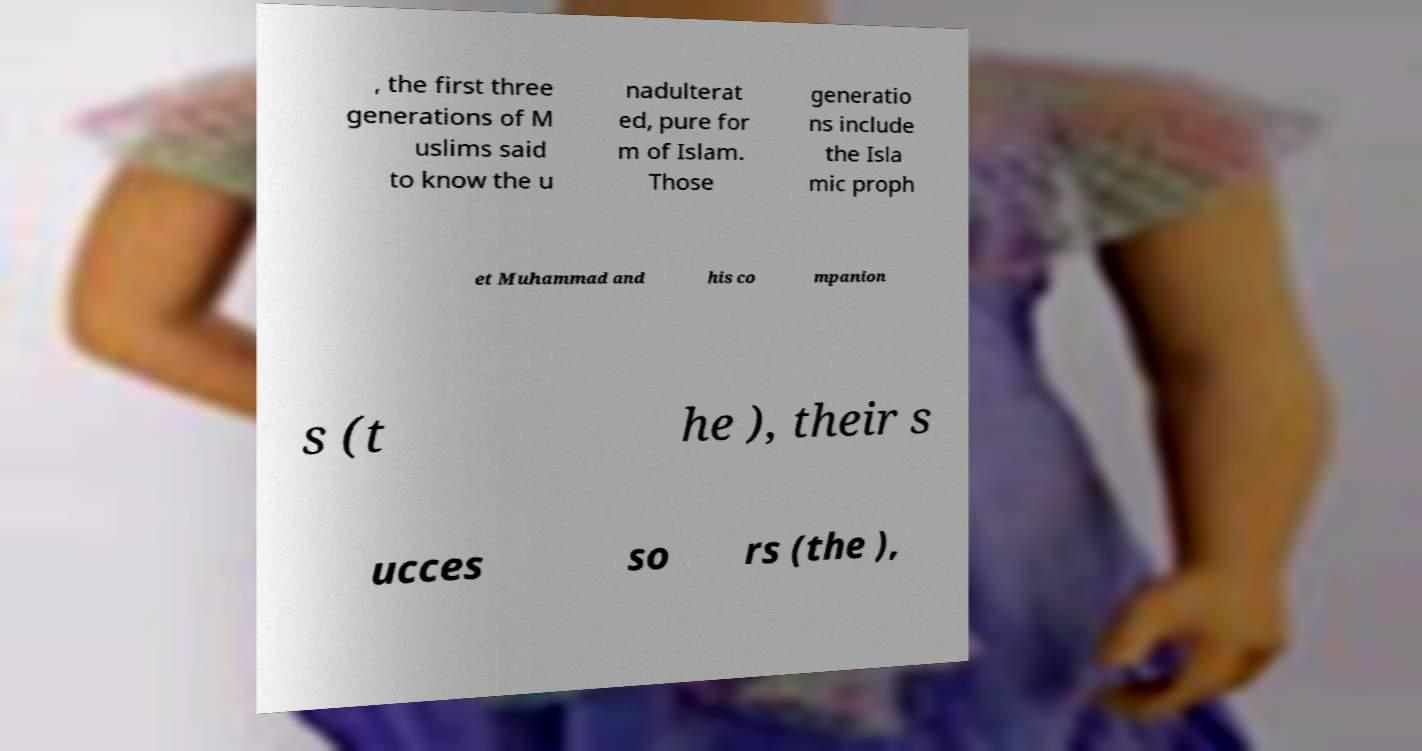There's text embedded in this image that I need extracted. Can you transcribe it verbatim? , the first three generations of M uslims said to know the u nadulterat ed, pure for m of Islam. Those generatio ns include the Isla mic proph et Muhammad and his co mpanion s (t he ), their s ucces so rs (the ), 